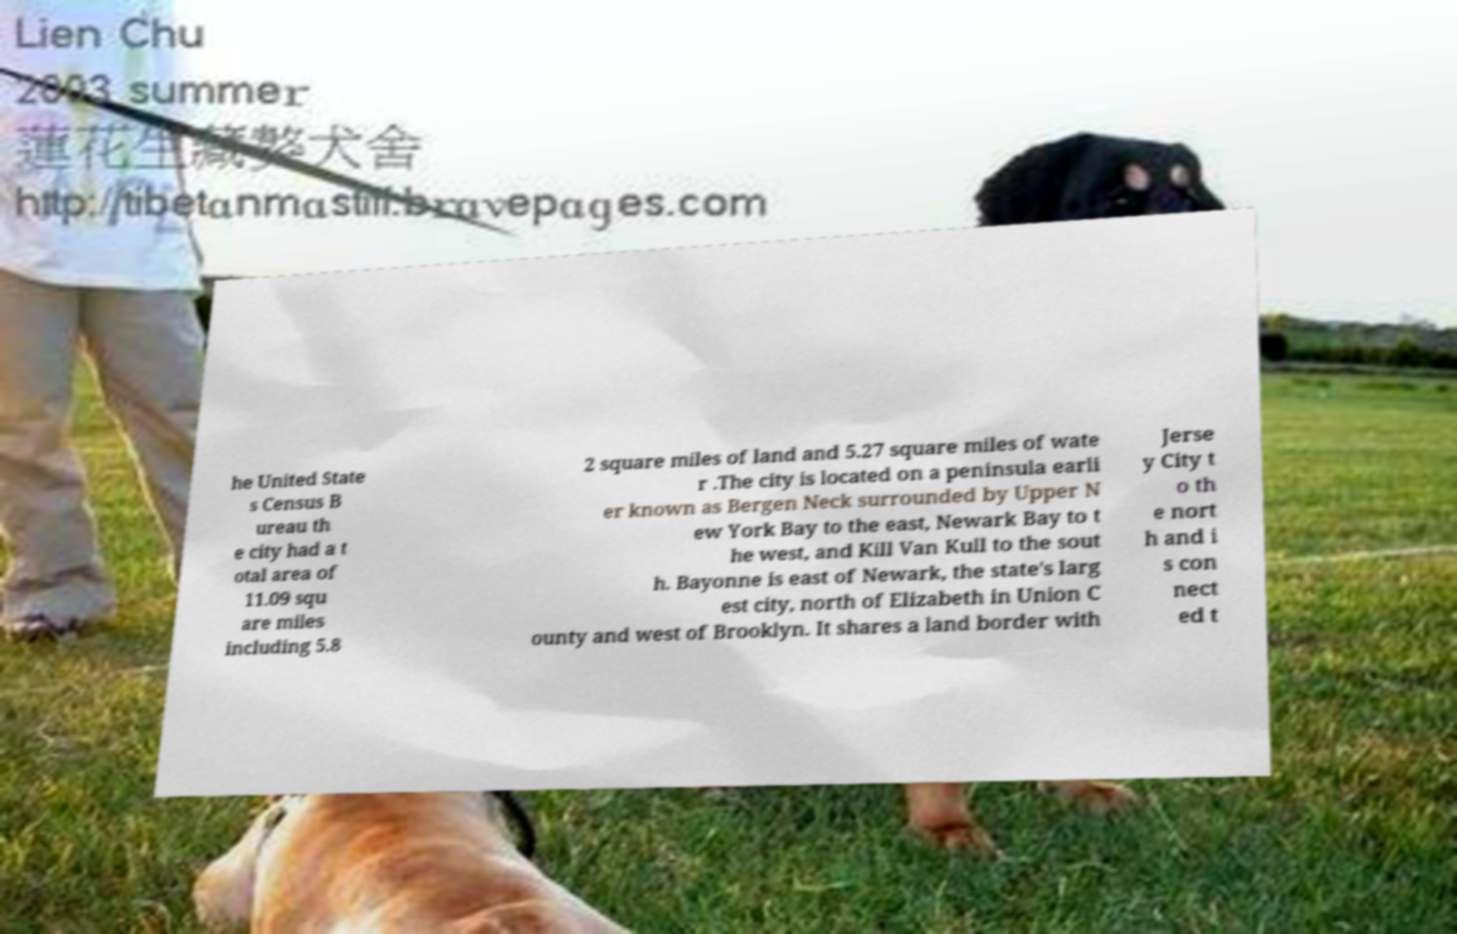There's text embedded in this image that I need extracted. Can you transcribe it verbatim? he United State s Census B ureau th e city had a t otal area of 11.09 squ are miles including 5.8 2 square miles of land and 5.27 square miles of wate r .The city is located on a peninsula earli er known as Bergen Neck surrounded by Upper N ew York Bay to the east, Newark Bay to t he west, and Kill Van Kull to the sout h. Bayonne is east of Newark, the state's larg est city, north of Elizabeth in Union C ounty and west of Brooklyn. It shares a land border with Jerse y City t o th e nort h and i s con nect ed t 